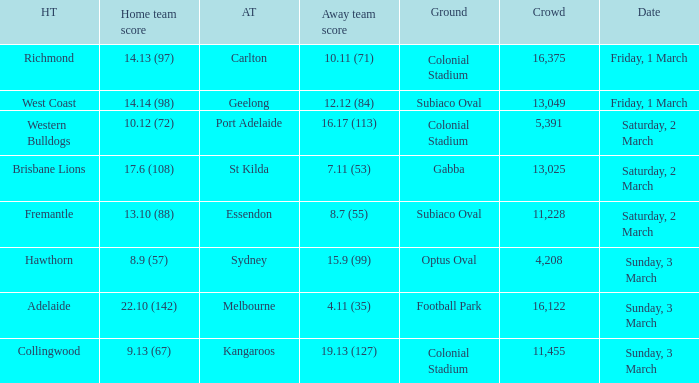When was the away team geelong? Friday, 1 March. 